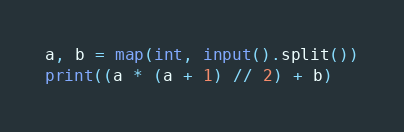Convert code to text. <code><loc_0><loc_0><loc_500><loc_500><_Python_>a, b = map(int, input().split())
print((a * (a + 1) // 2) + b)
</code> 